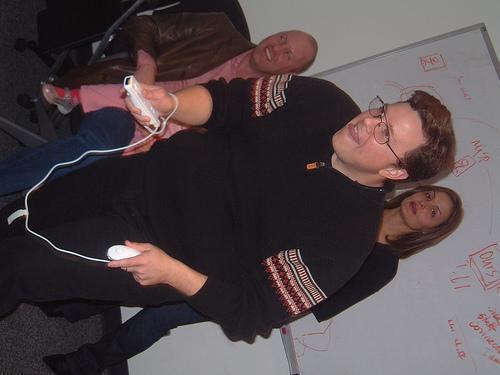How many players are there?
Indicate the correct response by choosing from the four available options to answer the question.
Options: Two, one, three, four. One. 